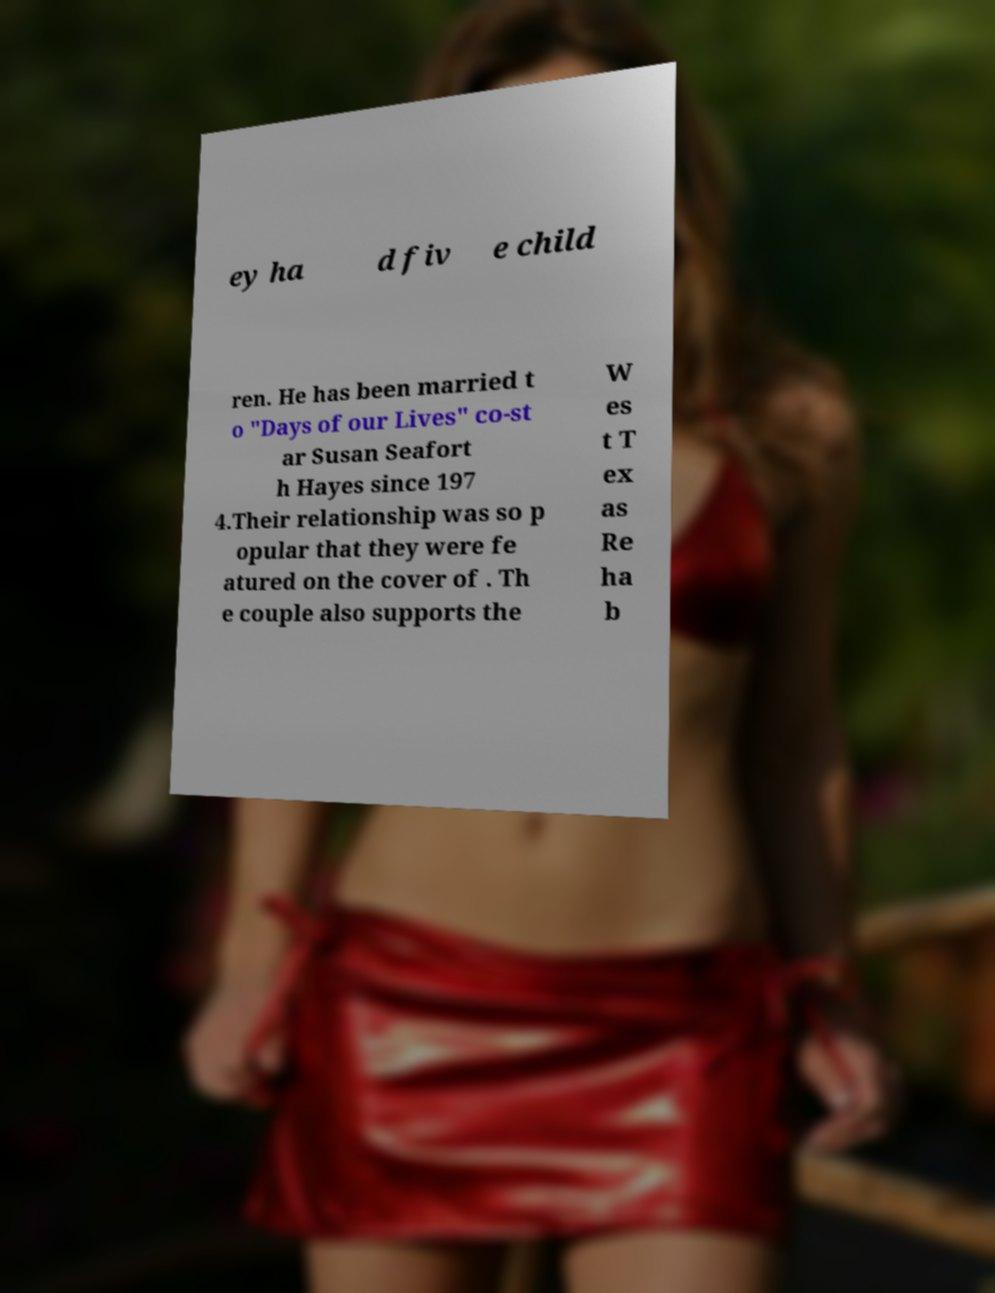I need the written content from this picture converted into text. Can you do that? ey ha d fiv e child ren. He has been married t o "Days of our Lives" co-st ar Susan Seafort h Hayes since 197 4.Their relationship was so p opular that they were fe atured on the cover of . Th e couple also supports the W es t T ex as Re ha b 